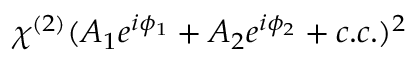<formula> <loc_0><loc_0><loc_500><loc_500>\chi ^ { ( 2 ) } ( A _ { 1 } e ^ { i \phi _ { 1 } } + A _ { 2 } e ^ { i \phi _ { 2 } } + c . c . ) ^ { 2 }</formula> 